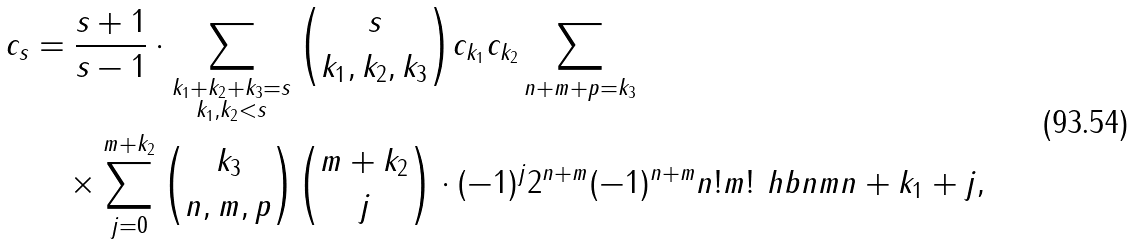Convert formula to latex. <formula><loc_0><loc_0><loc_500><loc_500>c _ { s } & = \frac { s + 1 } { s - 1 } \cdot \sum _ { \substack { k _ { 1 } + k _ { 2 } + k _ { 3 } = s \\ k _ { 1 } , k _ { 2 } < s } } \binom { s } { k _ { 1 } , k _ { 2 } , k _ { 3 } } c _ { k _ { 1 } } c _ { k _ { 2 } } \sum _ { n + m + p = k _ { 3 } } \\ & \quad \times \sum _ { j = 0 } ^ { m + k _ { 2 } } \binom { k _ { 3 } } { n , m , p } \binom { m + k _ { 2 } } { j } \cdot ( - 1 ) ^ { j } 2 ^ { n + m } ( - 1 ) ^ { n + m } n ! m ! \ h b { n } m { n + k _ { 1 } + j } ,</formula> 